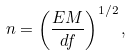<formula> <loc_0><loc_0><loc_500><loc_500>n = \left ( \frac { E M } { d f } \right ) ^ { 1 / 2 } ,</formula> 